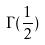<formula> <loc_0><loc_0><loc_500><loc_500>\Gamma ( \frac { 1 } { 2 } )</formula> 